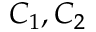Convert formula to latex. <formula><loc_0><loc_0><loc_500><loc_500>C _ { 1 } , C _ { 2 }</formula> 